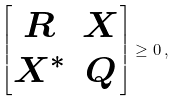<formula> <loc_0><loc_0><loc_500><loc_500>\begin{bmatrix} R & X \\ X ^ { * } & Q \end{bmatrix} \geq 0 \, ,</formula> 